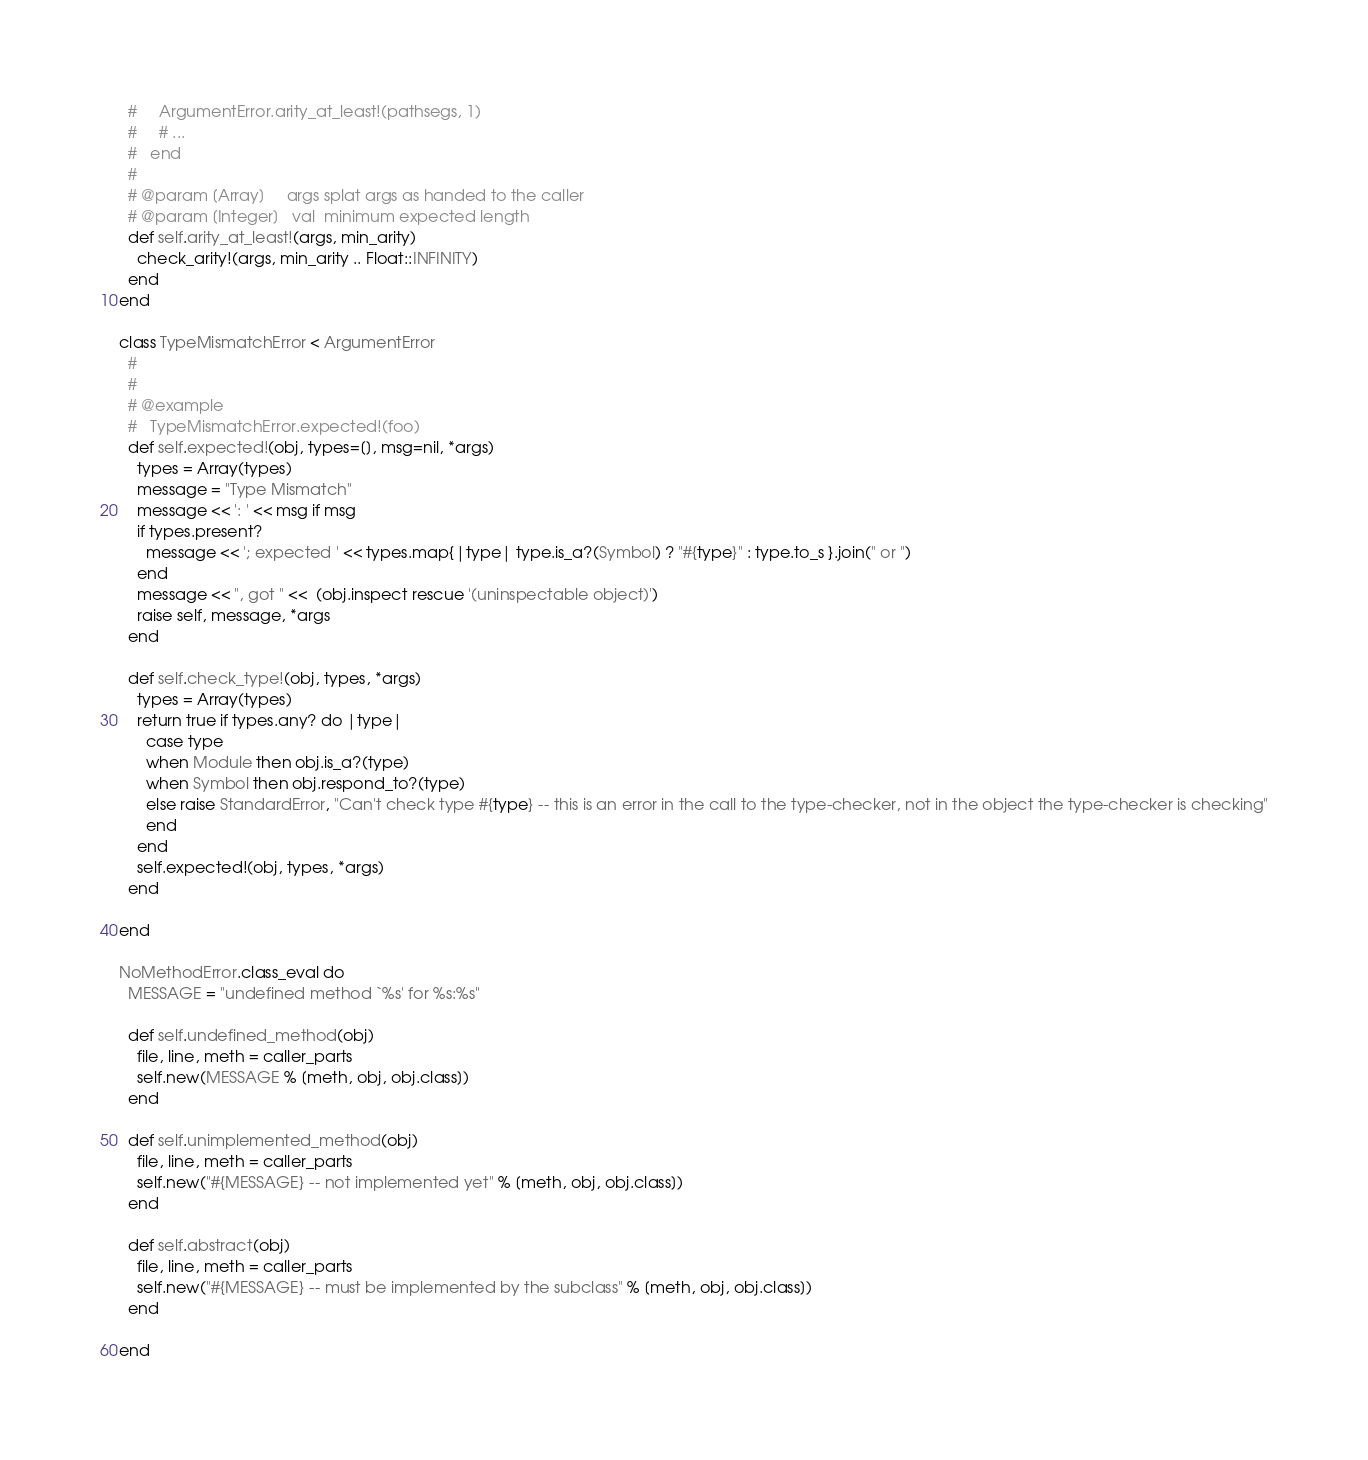Convert code to text. <code><loc_0><loc_0><loc_500><loc_500><_Ruby_>  #     ArgumentError.arity_at_least!(pathsegs, 1)
  #     # ...
  #   end
  #
  # @param [Array]     args splat args as handed to the caller
  # @param [Integer]   val  minimum expected length
  def self.arity_at_least!(args, min_arity)
    check_arity!(args, min_arity .. Float::INFINITY)
  end
end

class TypeMismatchError < ArgumentError
  #
  #
  # @example
  #   TypeMismatchError.expected!(foo)
  def self.expected!(obj, types=[], msg=nil, *args)
    types = Array(types)
    message = "Type Mismatch"
    message << ': ' << msg if msg
    if types.present?
      message << '; expected ' << types.map{|type| type.is_a?(Symbol) ? "#{type}" : type.to_s }.join(" or ")
    end
    message << ", got " <<  (obj.inspect rescue '(uninspectable object)')
    raise self, message, *args
  end

  def self.check_type!(obj, types, *args)
    types = Array(types)
    return true if types.any? do |type|
      case type
      when Module then obj.is_a?(type)
      when Symbol then obj.respond_to?(type)
      else raise StandardError, "Can't check type #{type} -- this is an error in the call to the type-checker, not in the object the type-checker is checking"
      end
    end
    self.expected!(obj, types, *args)
  end

end

NoMethodError.class_eval do
  MESSAGE = "undefined method `%s' for %s:%s"

  def self.undefined_method(obj)
    file, line, meth = caller_parts
    self.new(MESSAGE % [meth, obj, obj.class])
  end

  def self.unimplemented_method(obj)
    file, line, meth = caller_parts
    self.new("#{MESSAGE} -- not implemented yet" % [meth, obj, obj.class])
  end

  def self.abstract(obj)
    file, line, meth = caller_parts
    self.new("#{MESSAGE} -- must be implemented by the subclass" % [meth, obj, obj.class])
  end

end
</code> 